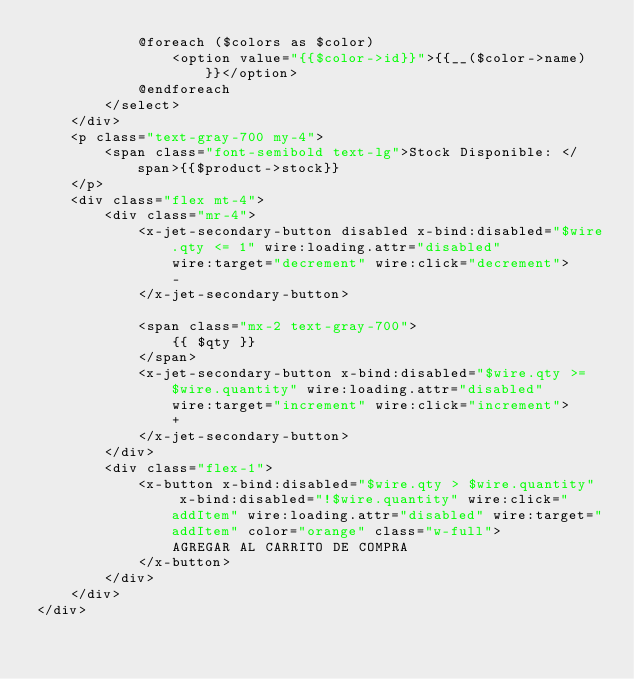<code> <loc_0><loc_0><loc_500><loc_500><_PHP_>            @foreach ($colors as $color)
                <option value="{{$color->id}}">{{__($color->name)}}</option>
            @endforeach
        </select>
    </div>
    <p class="text-gray-700 my-4">
        <span class="font-semibold text-lg">Stock Disponible: </span>{{$product->stock}}
    </p>
    <div class="flex mt-4">
        <div class="mr-4">
            <x-jet-secondary-button disabled x-bind:disabled="$wire.qty <= 1" wire:loading.attr="disabled"
                wire:target="decrement" wire:click="decrement">
                -
            </x-jet-secondary-button>

            <span class="mx-2 text-gray-700">
                {{ $qty }}
            </span>
            <x-jet-secondary-button x-bind:disabled="$wire.qty >= $wire.quantity" wire:loading.attr="disabled"
                wire:target="increment" wire:click="increment">
                +
            </x-jet-secondary-button>
        </div>
        <div class="flex-1">
            <x-button x-bind:disabled="$wire.qty > $wire.quantity"  x-bind:disabled="!$wire.quantity" wire:click="addItem" wire:loading.attr="disabled" wire:target="addItem" color="orange" class="w-full">
                AGREGAR AL CARRITO DE COMPRA
            </x-button>
        </div>
    </div>
</div>
</code> 